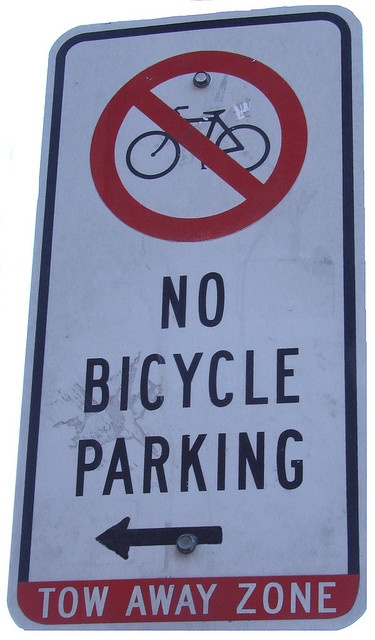Describe the objects in this image and their specific colors. I can see a bicycle in white, darkgray, navy, and black tones in this image. 